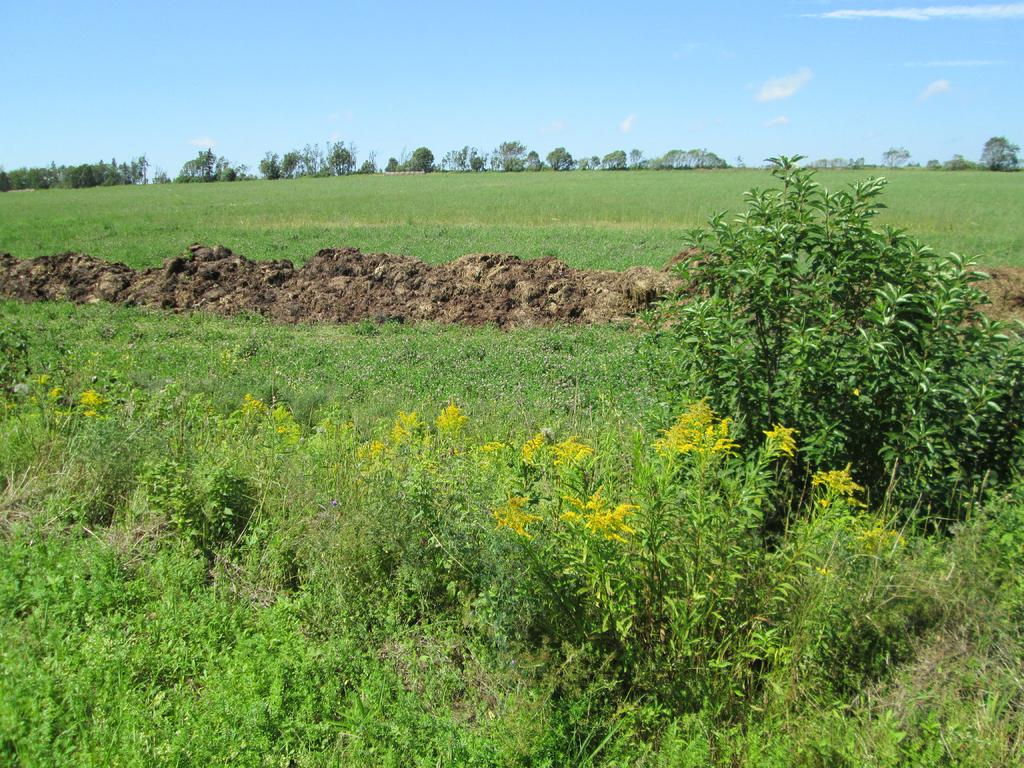What type of vegetation covers the land in the image? The land is covered with grass in the image. What other types of vegetation can be seen in the image? There are plants visible in the image. What can be seen in the distance in the image? There are trees in the distance in the image. What color is the sky in the image? The sky is blue in the image. Can you see a spark coming from the plants in the image? There is no spark visible in the image; it only features plants, trees, grass, and a blue sky. 